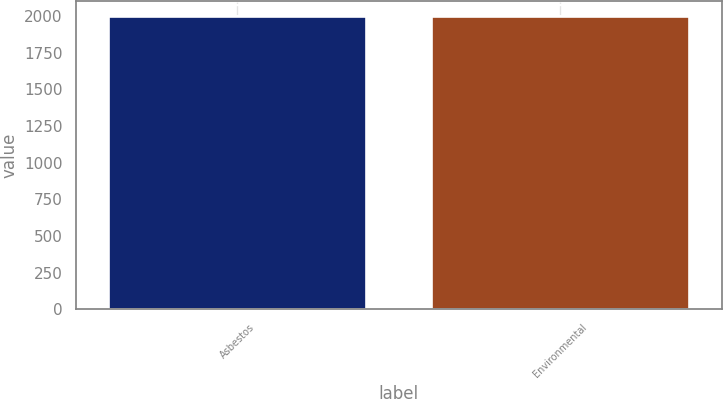<chart> <loc_0><loc_0><loc_500><loc_500><bar_chart><fcel>Asbestos<fcel>Environmental<nl><fcel>2002<fcel>2002.1<nl></chart> 